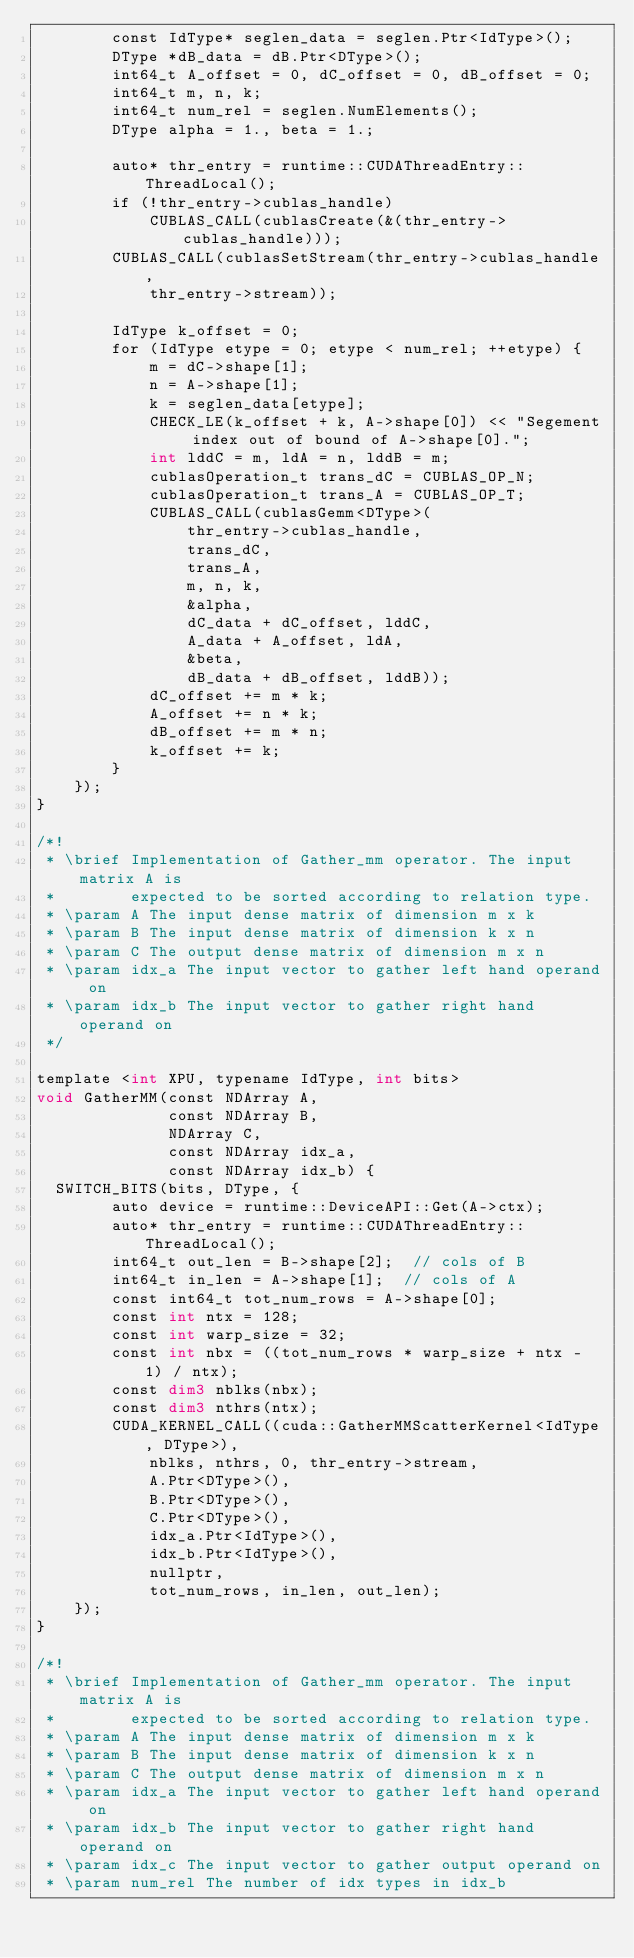<code> <loc_0><loc_0><loc_500><loc_500><_Cuda_>        const IdType* seglen_data = seglen.Ptr<IdType>();
        DType *dB_data = dB.Ptr<DType>();
        int64_t A_offset = 0, dC_offset = 0, dB_offset = 0;
        int64_t m, n, k;
        int64_t num_rel = seglen.NumElements();
        DType alpha = 1., beta = 1.;

        auto* thr_entry = runtime::CUDAThreadEntry::ThreadLocal();
        if (!thr_entry->cublas_handle)
            CUBLAS_CALL(cublasCreate(&(thr_entry->cublas_handle)));
        CUBLAS_CALL(cublasSetStream(thr_entry->cublas_handle,
            thr_entry->stream));

        IdType k_offset = 0;
        for (IdType etype = 0; etype < num_rel; ++etype) {
            m = dC->shape[1];
            n = A->shape[1];
            k = seglen_data[etype];
            CHECK_LE(k_offset + k, A->shape[0]) << "Segement index out of bound of A->shape[0].";
            int lddC = m, ldA = n, lddB = m;
            cublasOperation_t trans_dC = CUBLAS_OP_N;
            cublasOperation_t trans_A = CUBLAS_OP_T;
            CUBLAS_CALL(cublasGemm<DType>(
                thr_entry->cublas_handle,
                trans_dC,
                trans_A,
                m, n, k,
                &alpha,
                dC_data + dC_offset, lddC,
                A_data + A_offset, ldA,
                &beta,
                dB_data + dB_offset, lddB));
            dC_offset += m * k;
            A_offset += n * k;
            dB_offset += m * n;
            k_offset += k;
        }
    });
}

/*!
 * \brief Implementation of Gather_mm operator. The input matrix A is
 *        expected to be sorted according to relation type.
 * \param A The input dense matrix of dimension m x k
 * \param B The input dense matrix of dimension k x n
 * \param C The output dense matrix of dimension m x n
 * \param idx_a The input vector to gather left hand operand on
 * \param idx_b The input vector to gather right hand operand on
 */

template <int XPU, typename IdType, int bits>
void GatherMM(const NDArray A,
              const NDArray B,
              NDArray C,
              const NDArray idx_a,
              const NDArray idx_b) {
  SWITCH_BITS(bits, DType, {
        auto device = runtime::DeviceAPI::Get(A->ctx);
        auto* thr_entry = runtime::CUDAThreadEntry::ThreadLocal();
        int64_t out_len = B->shape[2];  // cols of B
        int64_t in_len = A->shape[1];  // cols of A
        const int64_t tot_num_rows = A->shape[0];
        const int ntx = 128;
        const int warp_size = 32;
        const int nbx = ((tot_num_rows * warp_size + ntx - 1) / ntx);
        const dim3 nblks(nbx);
        const dim3 nthrs(ntx);
        CUDA_KERNEL_CALL((cuda::GatherMMScatterKernel<IdType, DType>),
            nblks, nthrs, 0, thr_entry->stream,
            A.Ptr<DType>(),
            B.Ptr<DType>(),
            C.Ptr<DType>(),
            idx_a.Ptr<IdType>(),
            idx_b.Ptr<IdType>(),
            nullptr,
            tot_num_rows, in_len, out_len);
    });
}

/*!
 * \brief Implementation of Gather_mm operator. The input matrix A is
 *        expected to be sorted according to relation type.
 * \param A The input dense matrix of dimension m x k
 * \param B The input dense matrix of dimension k x n
 * \param C The output dense matrix of dimension m x n
 * \param idx_a The input vector to gather left hand operand on
 * \param idx_b The input vector to gather right hand operand on
 * \param idx_c The input vector to gather output operand on
 * \param num_rel The number of idx types in idx_b</code> 